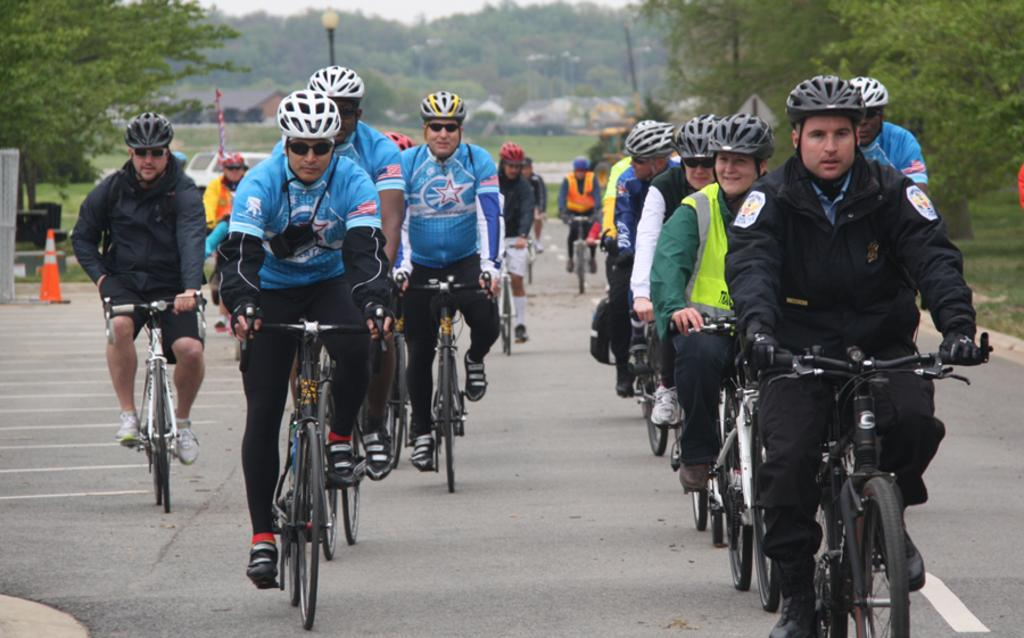What are the people in the image doing? The people in the image are cycling. What can be seen on either side of the road in the image? There are trees on either side of the road. What type of toothbrush can be seen in the image? There is no toothbrush present in the image. What is the group of people using to put out the fire in the image? There is no fire present in the image, so it is not possible to answer that question. 